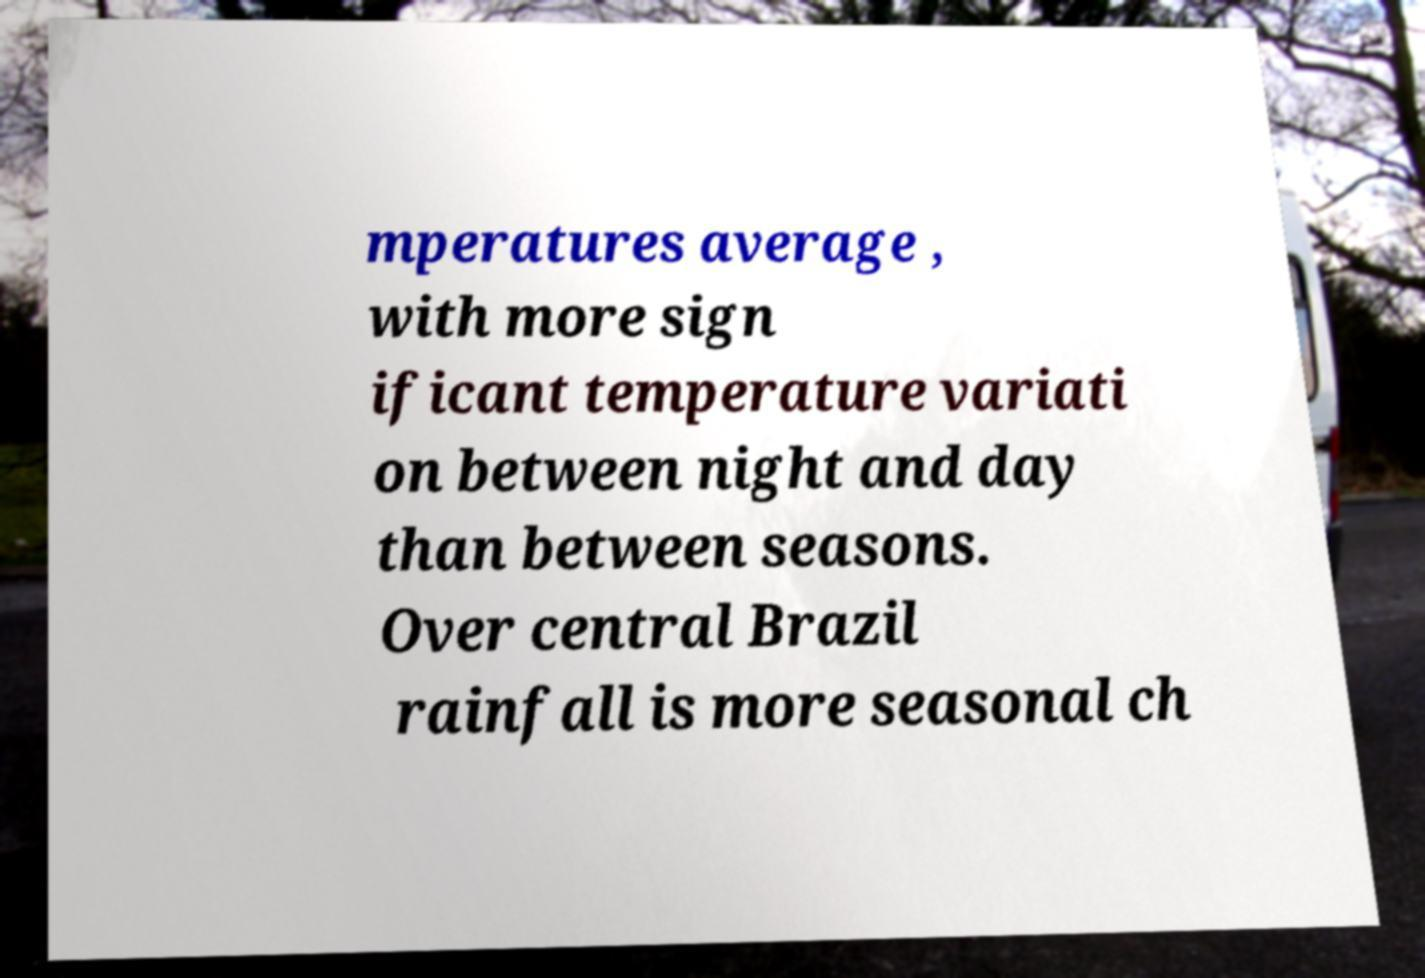What messages or text are displayed in this image? I need them in a readable, typed format. mperatures average , with more sign ificant temperature variati on between night and day than between seasons. Over central Brazil rainfall is more seasonal ch 